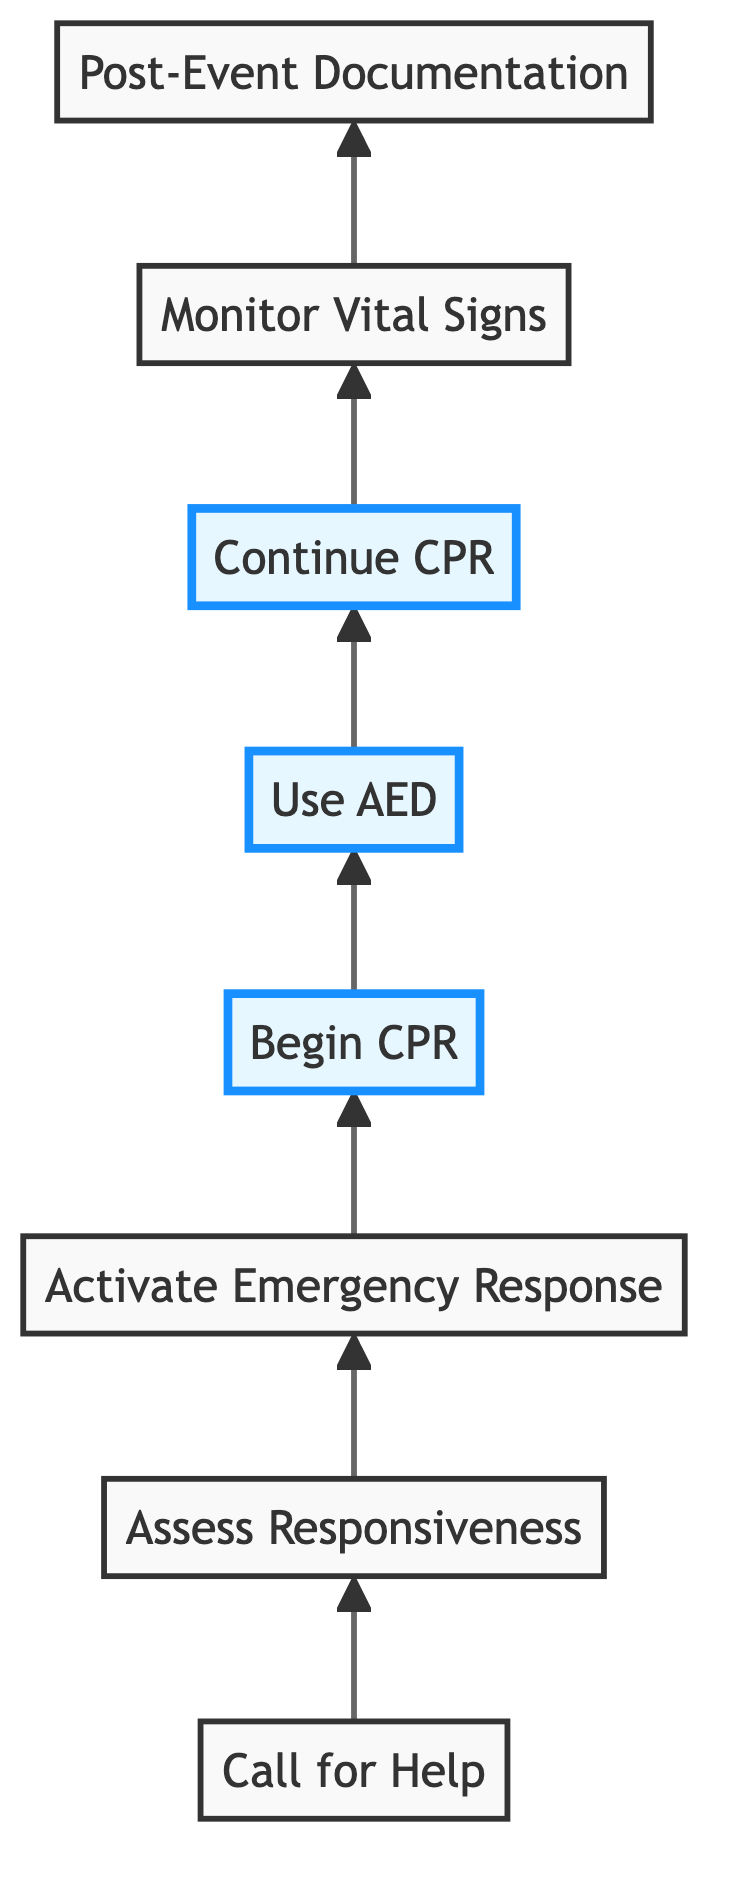What is the first action to take? The diagram indicates that the first action is "Call for Help." It is the starting point of the sequence and is positioned at the top of the flow.
Answer: Call for Help How many steps are there in total? By counting each distinct node in the diagram, we find that there are eight separate actions listed, from "Call for Help" to "Post-Event Documentation."
Answer: Eight What action follows "Assess Responsiveness"? The diagram shows that the next action after "Assess Responsiveness" is "Activate Emergency Response." This connection showcases the flow from one step to the next.
Answer: Activate Emergency Response Which actions are highlighted in the diagram? The diagram highlights the actions "Begin CPR," "Use AED," and "Continue CPR." These are visually emphasized, indicating their importance during the emergency response.
Answer: Begin CPR, Use AED, Continue CPR What is the last action in the response protocol? According to the flowchart, the last action specified in the sequence is "Post-Event Documentation," which follows all emergency response actions.
Answer: Post-Event Documentation What should be done after using the AED? The diagram states that after using the AED, the next action is to "Continue CPR." This indicates that CPR must persist after defibrillation until more help arrives.
Answer: Continue CPR Which two actions immediately precede "Monitor Vital Signs"? The diagram shows that "Continue CPR" and "Use AED" are the two actions that occur directly before "Monitor Vital Signs," demonstrating the continuous nature of emergency procedures.
Answer: Continue CPR, Use AED What is the purpose of "Post-Event Documentation"? According to the flowchart's description, the purpose of "Post-Event Documentation" is to document the event, actions taken, and patient response thoroughly, ensuring a proper record is kept.
Answer: Document the event, actions taken, and patient response thoroughly 